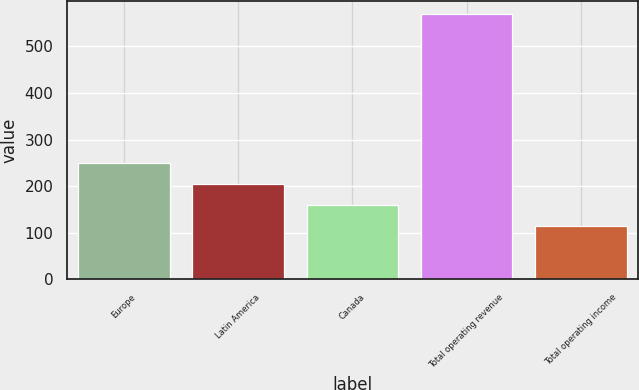Convert chart. <chart><loc_0><loc_0><loc_500><loc_500><bar_chart><fcel>Europe<fcel>Latin America<fcel>Canada<fcel>Total operating revenue<fcel>Total operating income<nl><fcel>250<fcel>204.5<fcel>159<fcel>568.5<fcel>113.5<nl></chart> 